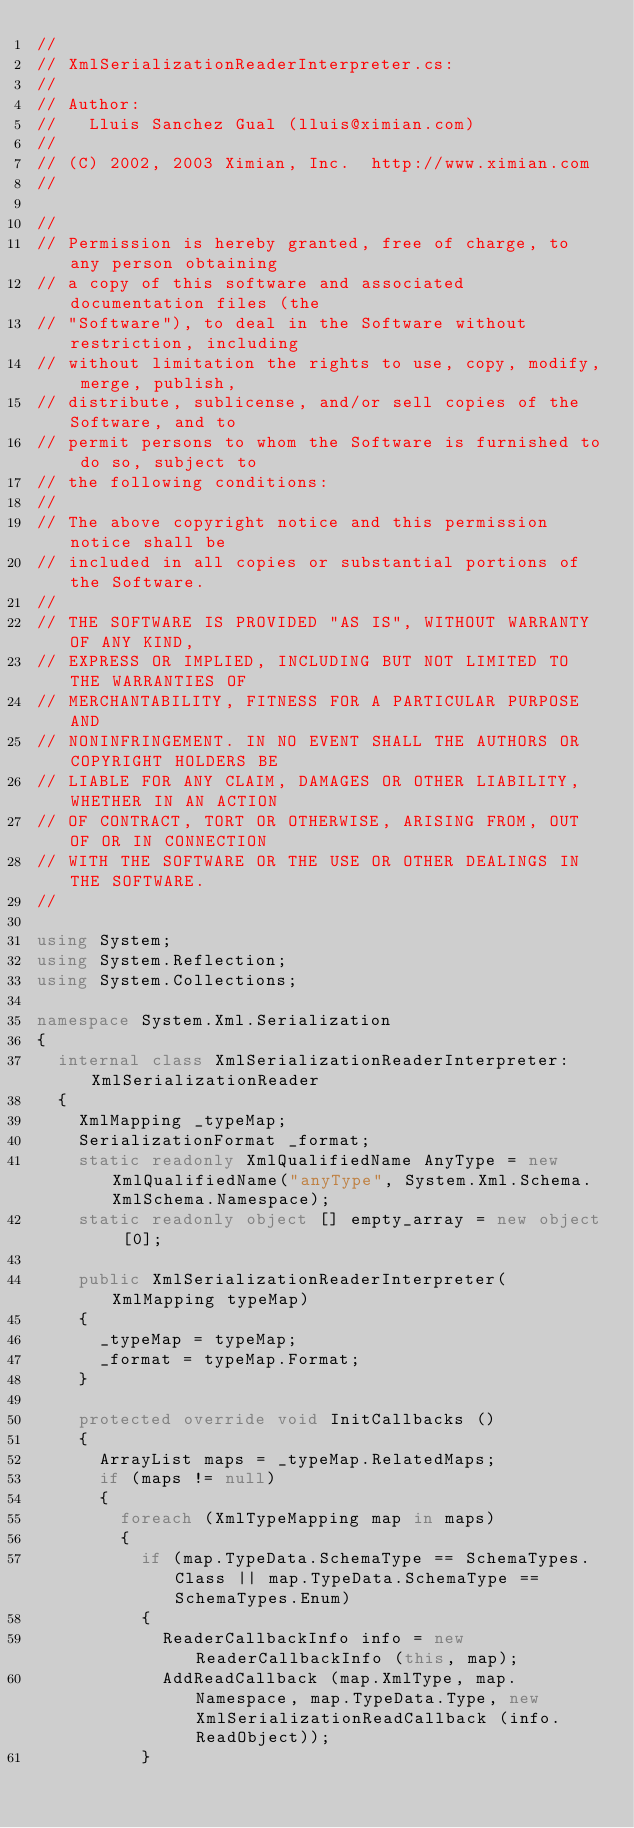Convert code to text. <code><loc_0><loc_0><loc_500><loc_500><_C#_>//
// XmlSerializationReaderInterpreter.cs: 
//
// Author:
//   Lluis Sanchez Gual (lluis@ximian.com)
//
// (C) 2002, 2003 Ximian, Inc.  http://www.ximian.com
//

//
// Permission is hereby granted, free of charge, to any person obtaining
// a copy of this software and associated documentation files (the
// "Software"), to deal in the Software without restriction, including
// without limitation the rights to use, copy, modify, merge, publish,
// distribute, sublicense, and/or sell copies of the Software, and to
// permit persons to whom the Software is furnished to do so, subject to
// the following conditions:
// 
// The above copyright notice and this permission notice shall be
// included in all copies or substantial portions of the Software.
// 
// THE SOFTWARE IS PROVIDED "AS IS", WITHOUT WARRANTY OF ANY KIND,
// EXPRESS OR IMPLIED, INCLUDING BUT NOT LIMITED TO THE WARRANTIES OF
// MERCHANTABILITY, FITNESS FOR A PARTICULAR PURPOSE AND
// NONINFRINGEMENT. IN NO EVENT SHALL THE AUTHORS OR COPYRIGHT HOLDERS BE
// LIABLE FOR ANY CLAIM, DAMAGES OR OTHER LIABILITY, WHETHER IN AN ACTION
// OF CONTRACT, TORT OR OTHERWISE, ARISING FROM, OUT OF OR IN CONNECTION
// WITH THE SOFTWARE OR THE USE OR OTHER DEALINGS IN THE SOFTWARE.
//

using System;
using System.Reflection;
using System.Collections;

namespace System.Xml.Serialization
{
	internal class XmlSerializationReaderInterpreter: XmlSerializationReader
	{
		XmlMapping _typeMap;
		SerializationFormat _format;
		static readonly XmlQualifiedName AnyType = new XmlQualifiedName("anyType", System.Xml.Schema.XmlSchema.Namespace);
		static readonly object [] empty_array = new object [0];

		public XmlSerializationReaderInterpreter(XmlMapping typeMap)
		{
			_typeMap = typeMap;
			_format = typeMap.Format;
		}

		protected override void InitCallbacks ()
		{
			ArrayList maps = _typeMap.RelatedMaps;
			if (maps != null)
			{
				foreach (XmlTypeMapping map in maps)  
				{
					if (map.TypeData.SchemaType == SchemaTypes.Class || map.TypeData.SchemaType == SchemaTypes.Enum)
					{
						ReaderCallbackInfo info = new ReaderCallbackInfo (this, map);
						AddReadCallback (map.XmlType, map.Namespace, map.TypeData.Type, new XmlSerializationReadCallback (info.ReadObject));
					}</code> 